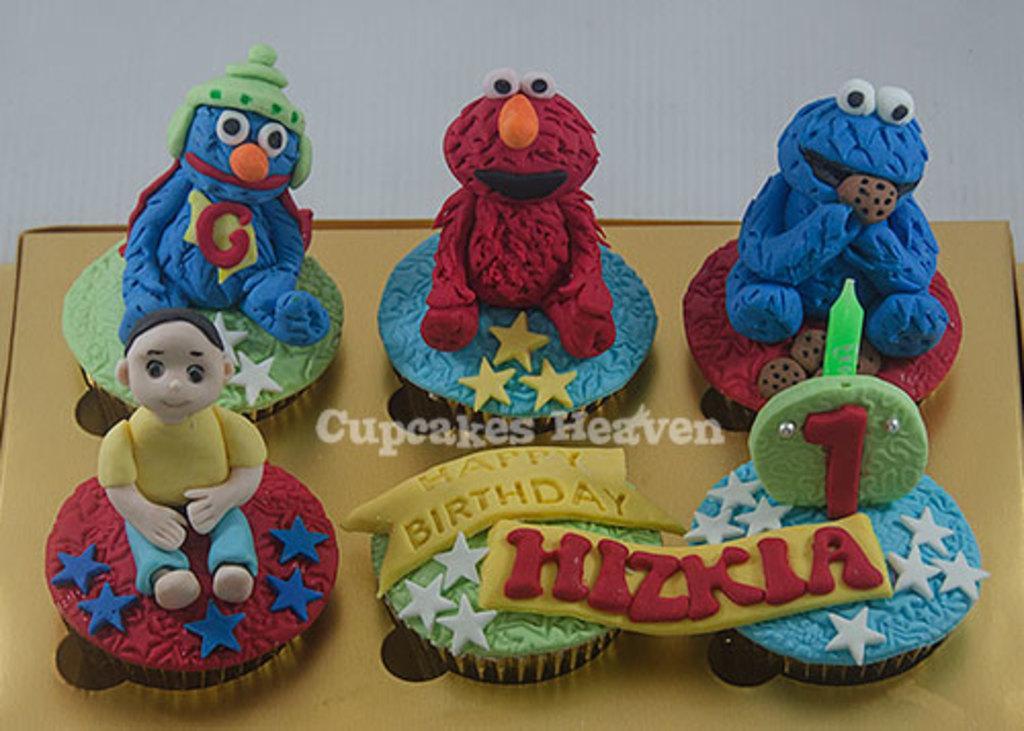In one or two sentences, can you explain what this image depicts? In the picture I can see a few cupcakes are placed here. The background of the image is in white color. Here I can see the watermark in the center of the image. 